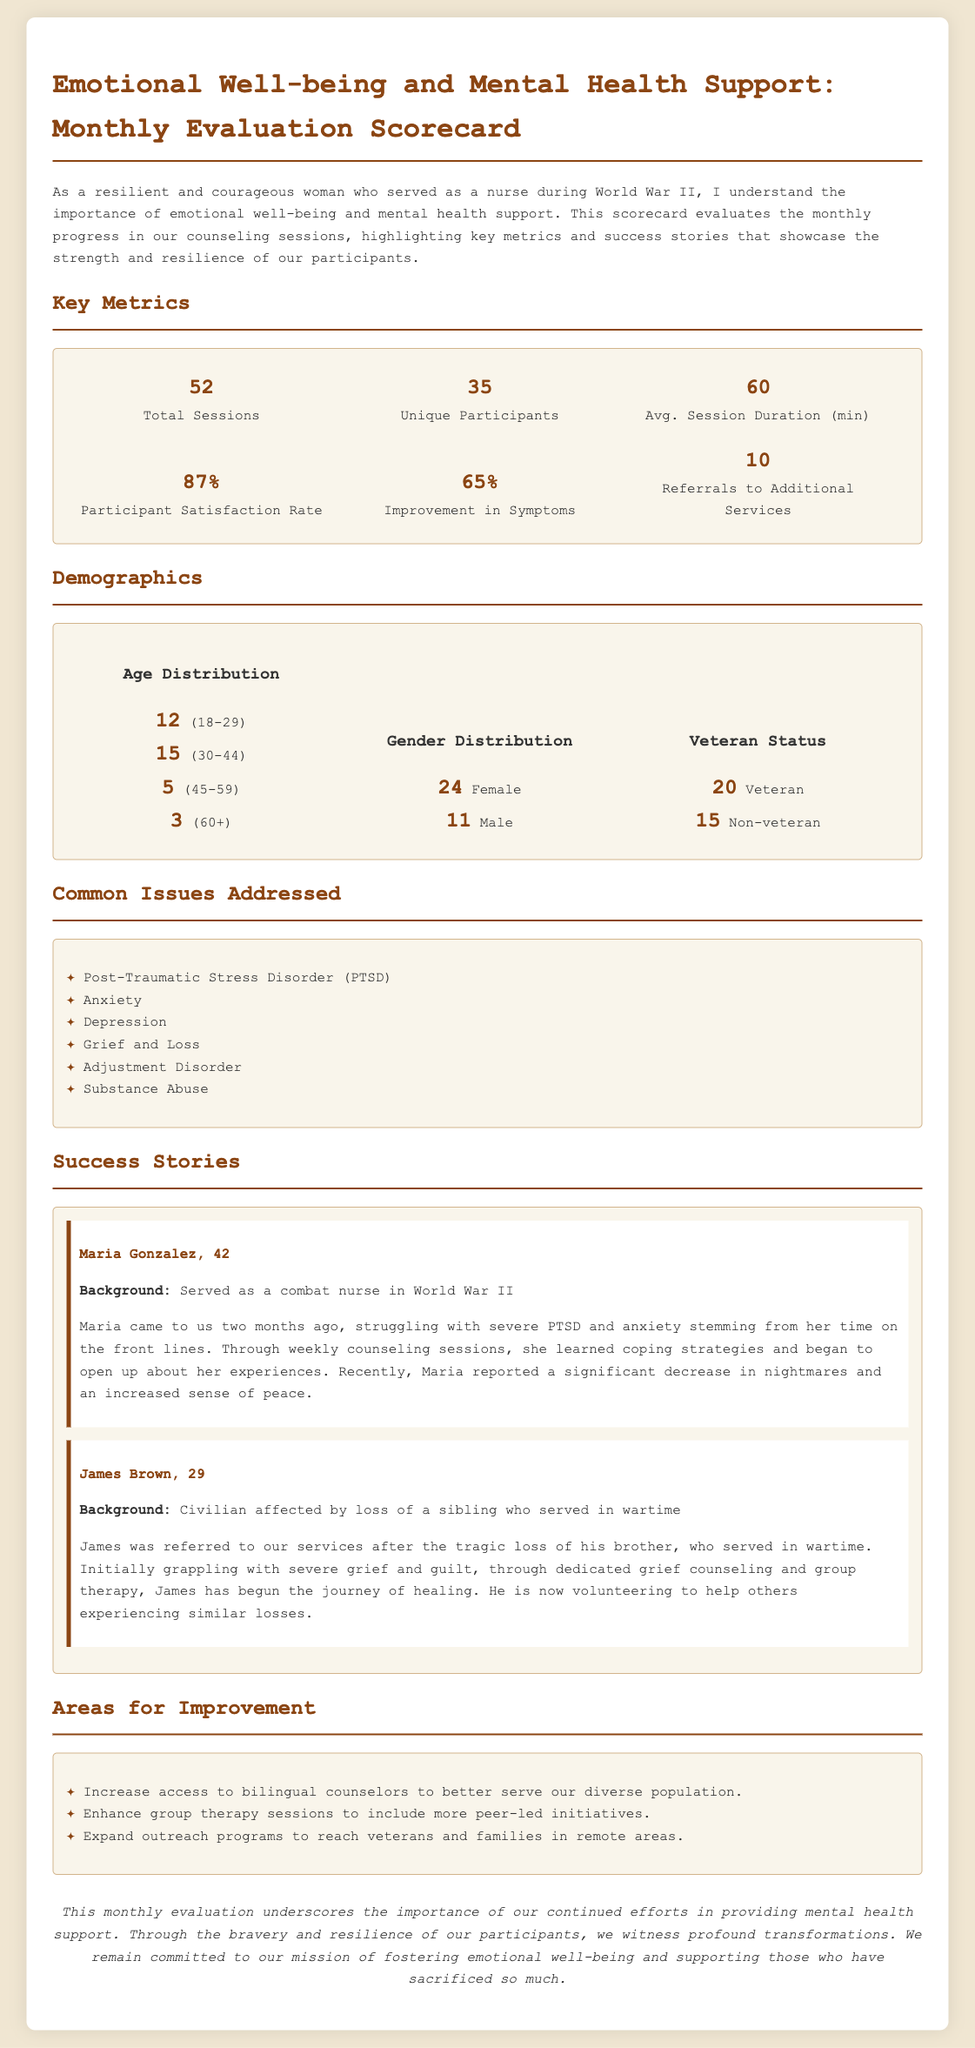What is the total number of counseling sessions conducted? The total number of counseling sessions is listed in the Key Metrics section of the document.
Answer: 52 How many unique participants attended the sessions? The number of unique participants is also found in the Key Metrics section of the document.
Answer: 35 What is the average session duration in minutes? The average session duration is specified in the Key Metrics section.
Answer: 60 What is the participant satisfaction rate percentage? The participant satisfaction rate is provided in the Key Metrics section of the document.
Answer: 87% How many veterans participated in the counseling sessions? The number of veterans who participated is given in the Demographics section.
Answer: 20 What common issue was addressed related to emotional trauma? The common issues addressed are listed in the Common Issues section.
Answer: Post-Traumatic Stress Disorder (PTSD) Who is one of the success stories featured in the document? The success stories section provides names of individuals who improved through the program.
Answer: Maria Gonzalez What percentage of participants showed improvement in symptoms? The percentage of improvement in symptoms is available in the Key Metrics.
Answer: 65% What recommendation is suggested for improving outreach in the document? The Areas for Improvement section contains suggestions to enhance service delivery.
Answer: Expand outreach programs 